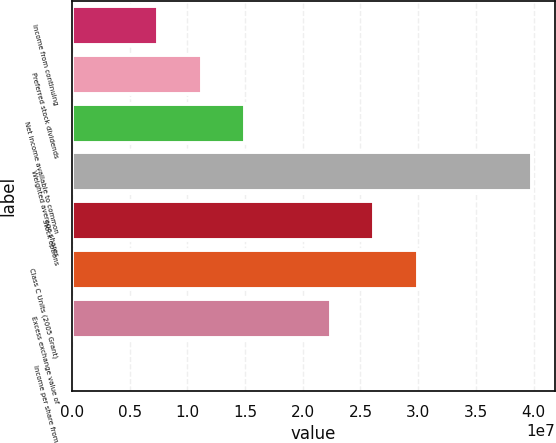<chart> <loc_0><loc_0><loc_500><loc_500><bar_chart><fcel>Income from continuing<fcel>Preferred stock dividends<fcel>Net income available to common<fcel>Weighted average shares<fcel>Stock options<fcel>Class C Units (2005 Grant)<fcel>Excess exchange value of<fcel>Income per share from<nl><fcel>7.48844e+06<fcel>1.12327e+07<fcel>1.49769e+07<fcel>3.98792e+07<fcel>2.62095e+07<fcel>2.99538e+07<fcel>2.24653e+07<fcel>0.2<nl></chart> 